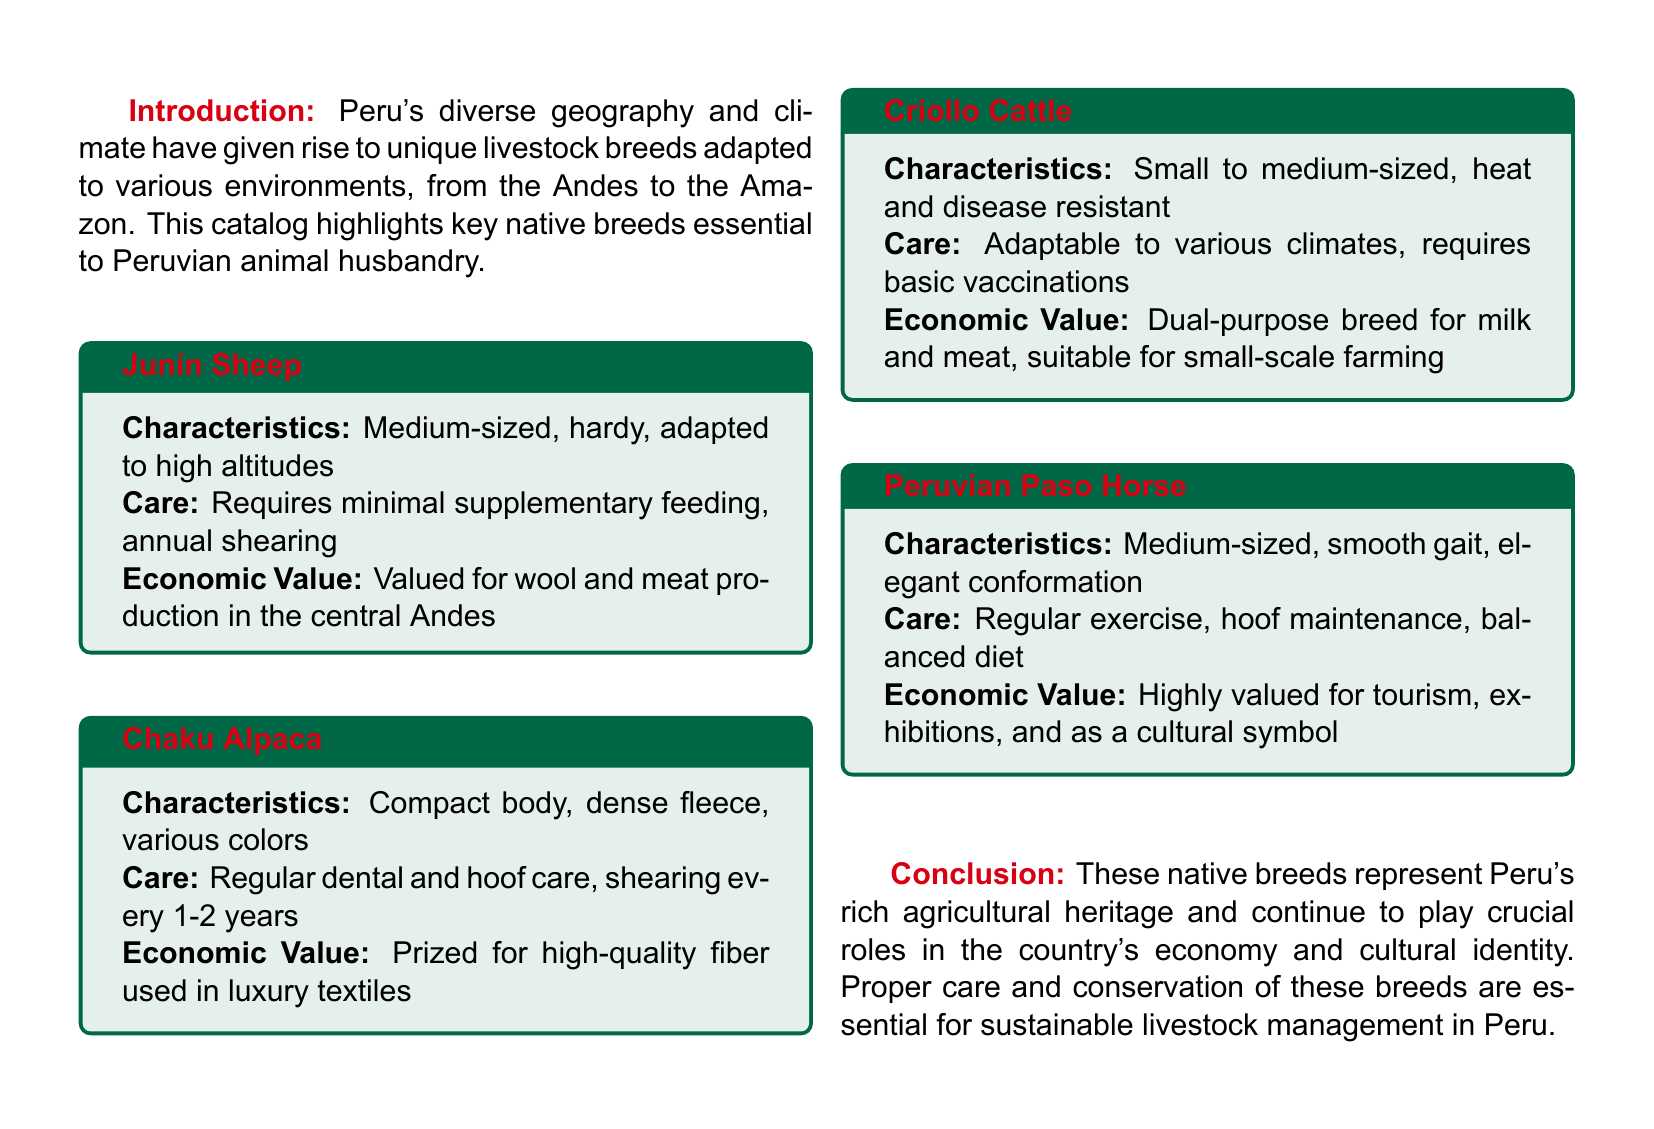What is the first native breed listed in the catalog? The first breed mentioned in the catalog is Junín Sheep.
Answer: Junín Sheep What is the primary economic value of Chaku Alpaca? The economic value of Chaku Alpaca is highlighted as prized for high-quality fiber used in luxury textiles.
Answer: High-quality fiber What is a care requirement for Criollo Cattle? One of the care requirements for Criollo Cattle is basic vaccinations.
Answer: Basic vaccinations What type of livestock is the Peruvian Paso Horse primarily valued for? The Peruvian Paso Horse is primarily valued for tourism and exhibitions.
Answer: Tourism What characteristic is associated with Junín Sheep? Junín Sheep are described as medium-sized, hardy, and adapted to high altitudes.
Answer: Medium-sized, hardy What is the shearing frequency for Chaku Alpaca? Chaku Alpaca requires shearing every 1-2 years.
Answer: Every 1-2 years How many native breeds are emphasized in the catalog? The catalog emphasizes four native breeds of livestock in total.
Answer: Four Which breed is described as heat and disease resistant? Criollo Cattle are described as heat and disease resistant.
Answer: Criollo Cattle What is the conclusion about the native breeds in the document? The conclusion highlights that these breeds represent Peru's rich agricultural heritage.
Answer: Rich agricultural heritage 